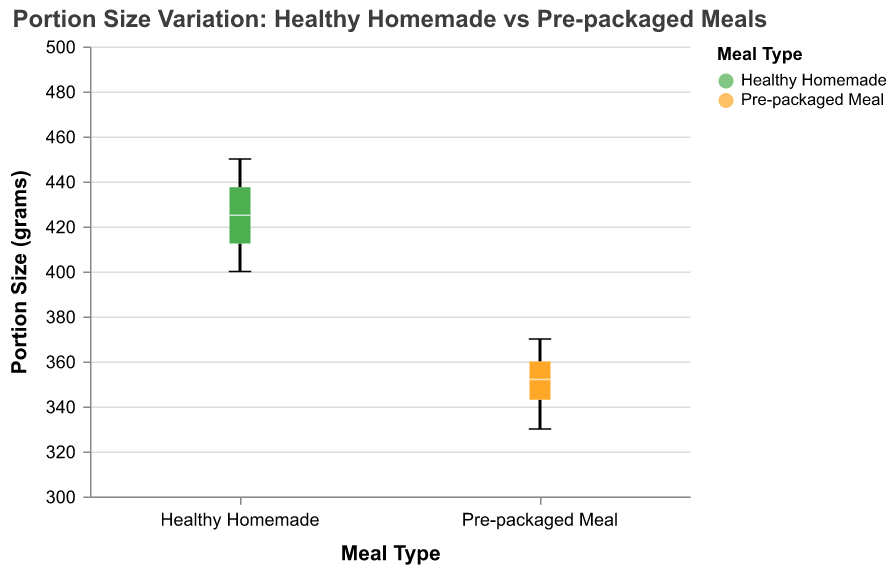What is the title of the box plot? The title is located at the top of the figure, and it describes the subject of the plot.
Answer: "Portion Size Variation: Healthy Homemade vs Pre-packaged Meals" What are the two recipe types compared in the plot? The x-axis shows the categories being compared.
Answer: Healthy Homemade and Pre-packaged Meal Which recipe type has a higher median portion size? The median is represented by the horizontal line inside the box.
Answer: Healthy Homemade What is the range of portion sizes for Healthy Homemade meals? The range is indicated by the vertical extent of the boxplot from the minimum to the maximum.
Answer: 400 to 450 grams Which recipe type has more variation in portion sizes? The variation can be determined by the height of the box and the length of the whiskers, representing the interquartile range and the full range of the data, respectively.
Answer: Healthy Homemade What is the median portion size for Pre-packaged meals? Look at the horizontal line inside the box for the Pre-packaged Meal category.
Answer: 355 grams How does the upper quartile for Healthy Homemade compare to the upper quartile for Pre-packaged Meals? The upper quartile is the top edge of the box. Compare the values for both recipe types.
Answer: Healthy Homemade has a higher upper quartile What is the interquartile range (IQR) for Pre-packaged meals? The IQR is the range between the first quartile and the third quartile.
Answer: 340 to 365 grams What are the maximum portion sizes for both recipe types? The maximum portion size is indicated by the top whisker of each boxplot.
Answer: 450 grams for Healthy Homemade, 370 grams for Pre-packaged Meal Which recipe type potentially provides more consistent portion sizes? Consistency can be inferred from the smaller range between the minimum and maximum whiskers, as well as a smaller interquartile range.
Answer: Pre-packaged Meal 